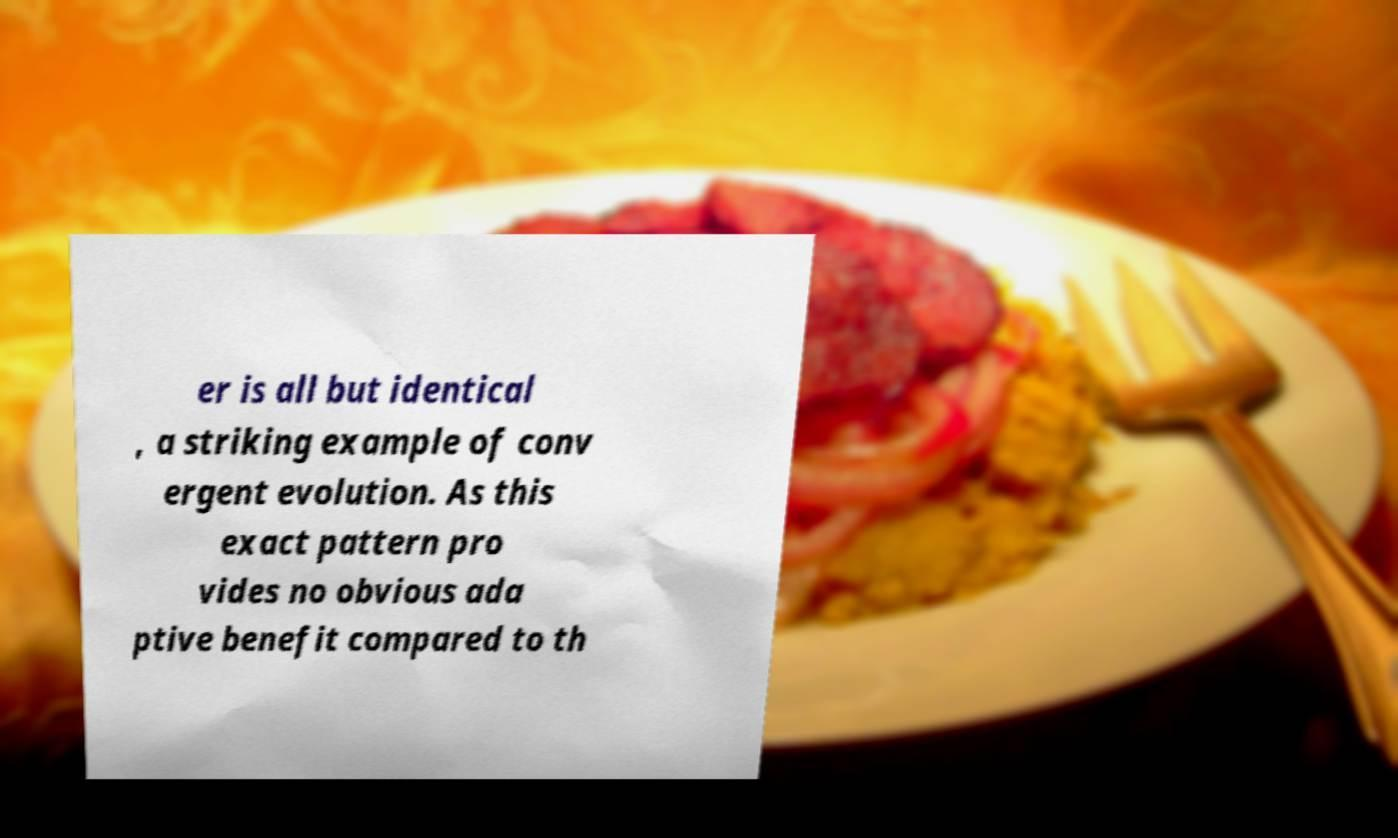What messages or text are displayed in this image? I need them in a readable, typed format. er is all but identical , a striking example of conv ergent evolution. As this exact pattern pro vides no obvious ada ptive benefit compared to th 